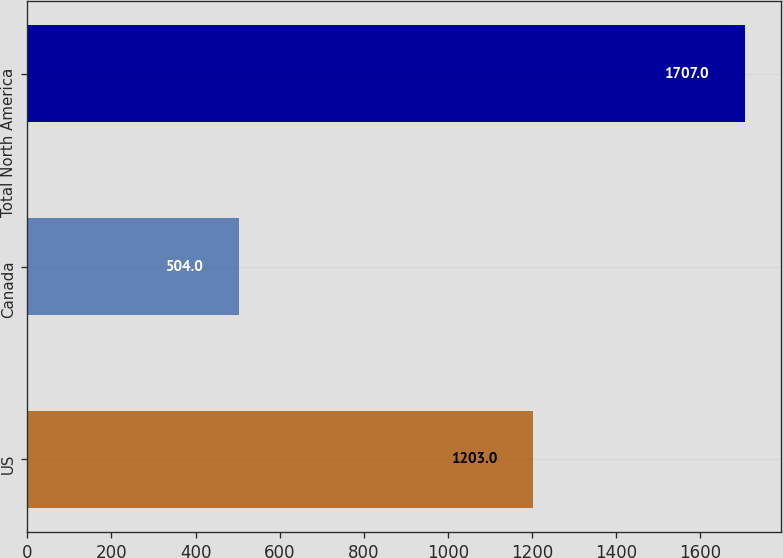Convert chart to OTSL. <chart><loc_0><loc_0><loc_500><loc_500><bar_chart><fcel>US<fcel>Canada<fcel>Total North America<nl><fcel>1203<fcel>504<fcel>1707<nl></chart> 